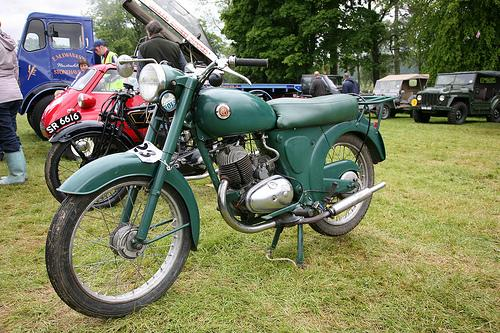Describe the footwear and clothing that is lying around. There are light green mud boots, a light pink winter coat, and a pair of blue jeans. List all the types of vehicles present in the image along with their colors. Green motorcycle, black motorcycle, small red vehicle, parked green jeep, parked brown jeep, blue truck cab, red car, and black truck. What are the three main colors of the vehicles in the image? Green, black, and red are the three main colors of the vehicles. Name the objects on the bike and describe their colors. There are black wheels and a chrome pipe on the bike. Which object is closest to the girl standing near the truck? A light pink winter coat is closest to the girl standing near the truck. Count the total number of trees in the background of the image. There are two groups of green trees in the background. What is behind the green and black parked motorcycles on the grass? A small red vehicle, a red car, and a blue truck are behind the parked motorcycles. What can you infer about the season based on the clothing and footwear in the image? It's likely a transitional season like spring or fall, as there are both winter coats and mud boots present. Identify the color and type of the two motorcycles parked in the image. There is a green parked motorcycle and a black parked motorcycle. How many motorcycles are parked on the grass, and what are their colors? There are two motorcycles parked on the grass, one green and one black. 